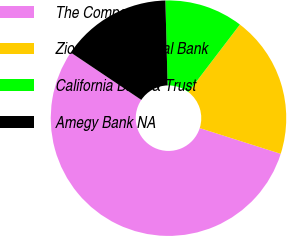<chart> <loc_0><loc_0><loc_500><loc_500><pie_chart><fcel>The Company<fcel>Zions First National Bank<fcel>California Bank & Trust<fcel>Amegy Bank NA<nl><fcel>54.52%<fcel>19.53%<fcel>10.79%<fcel>15.16%<nl></chart> 